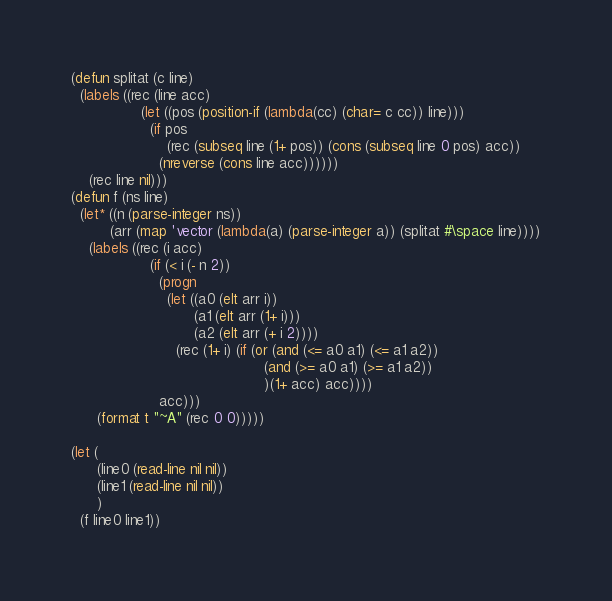<code> <loc_0><loc_0><loc_500><loc_500><_Lisp_>(defun splitat (c line)
  (labels ((rec (line acc)
				(let ((pos (position-if (lambda(cc) (char= c cc)) line)))
				  (if pos
					  (rec (subseq line (1+ pos)) (cons (subseq line 0 pos) acc))
					(nreverse (cons line acc))))))
	(rec line nil)))
(defun f (ns line)
  (let* ((n (parse-integer ns))
		 (arr (map 'vector (lambda(a) (parse-integer a)) (splitat #\space line))))
	(labels ((rec (i acc)
				  (if (< i (- n 2))
					(progn
					  (let ((a0 (elt arr i))
							(a1 (elt arr (1+ i)))
							(a2 (elt arr (+ i 2))))
						(rec (1+ i) (if (or (and (<= a0 a1) (<= a1 a2))
											(and (>= a0 a1) (>= a1 a2))
											)(1+ acc) acc))))
					acc)))
	  (format t "~A" (rec 0 0)))))

(let (
	  (line0 (read-line nil nil))
	  (line1 (read-line nil nil))
	  )
  (f line0 line1))
</code> 